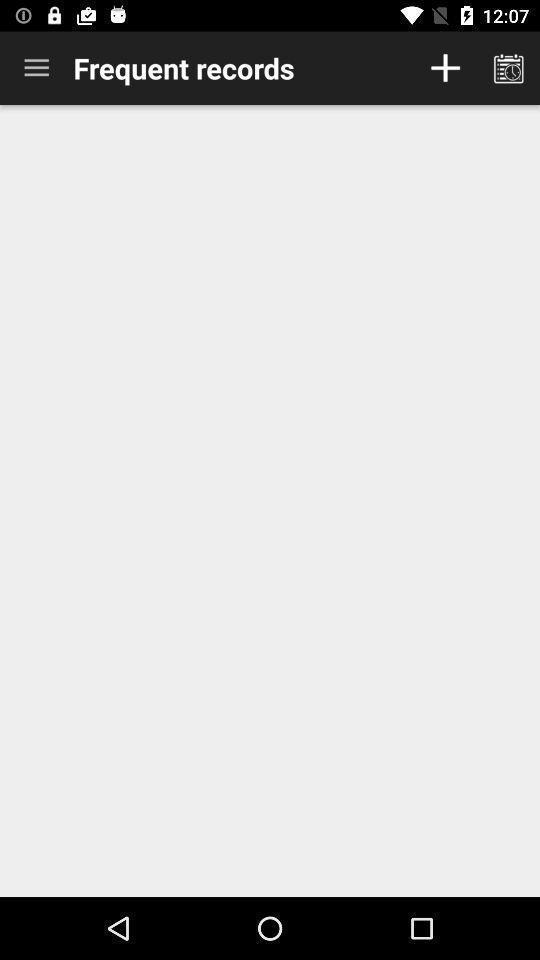Give me a summary of this screen capture. Display of the mobile with frequent records. 